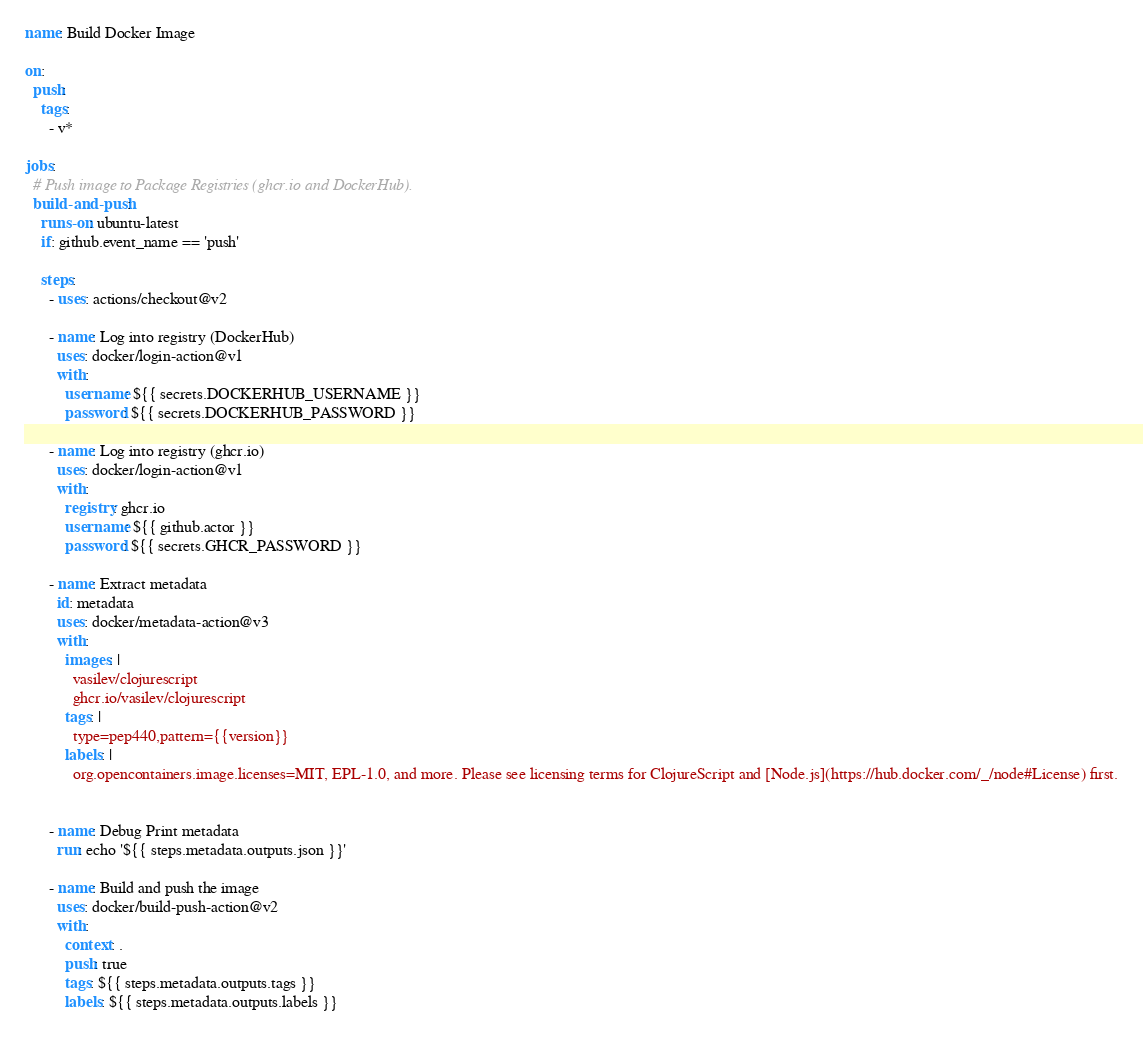<code> <loc_0><loc_0><loc_500><loc_500><_YAML_>name: Build Docker Image

on:
  push:
    tags:
      - v*

jobs:
  # Push image to Package Registries (ghcr.io and DockerHub).
  build-and-push:
    runs-on: ubuntu-latest
    if: github.event_name == 'push'

    steps:
      - uses: actions/checkout@v2

      - name: Log into registry (DockerHub)
        uses: docker/login-action@v1
        with:
          username: ${{ secrets.DOCKERHUB_USERNAME }}
          password: ${{ secrets.DOCKERHUB_PASSWORD }}
          
      - name: Log into registry (ghcr.io)
        uses: docker/login-action@v1
        with:
          registry: ghcr.io
          username: ${{ github.actor }}
          password: ${{ secrets.GHCR_PASSWORD }}
          
      - name: Extract metadata
        id: metadata
        uses: docker/metadata-action@v3
        with:
          images: |
            vasilev/clojurescript
            ghcr.io/vasilev/clojurescript
          tags: |
            type=pep440,pattern={{version}}
          labels: |
            org.opencontainers.image.licenses=MIT, EPL-1.0, and more. Please see licensing terms for ClojureScript and [Node.js](https://hub.docker.com/_/node#License) first.

            
      - name: Debug Print metadata
        run: echo '${{ steps.metadata.outputs.json }}'

      - name: Build and push the image
        uses: docker/build-push-action@v2
        with:
          context: .
          push: true
          tags: ${{ steps.metadata.outputs.tags }}
          labels: ${{ steps.metadata.outputs.labels }}
</code> 